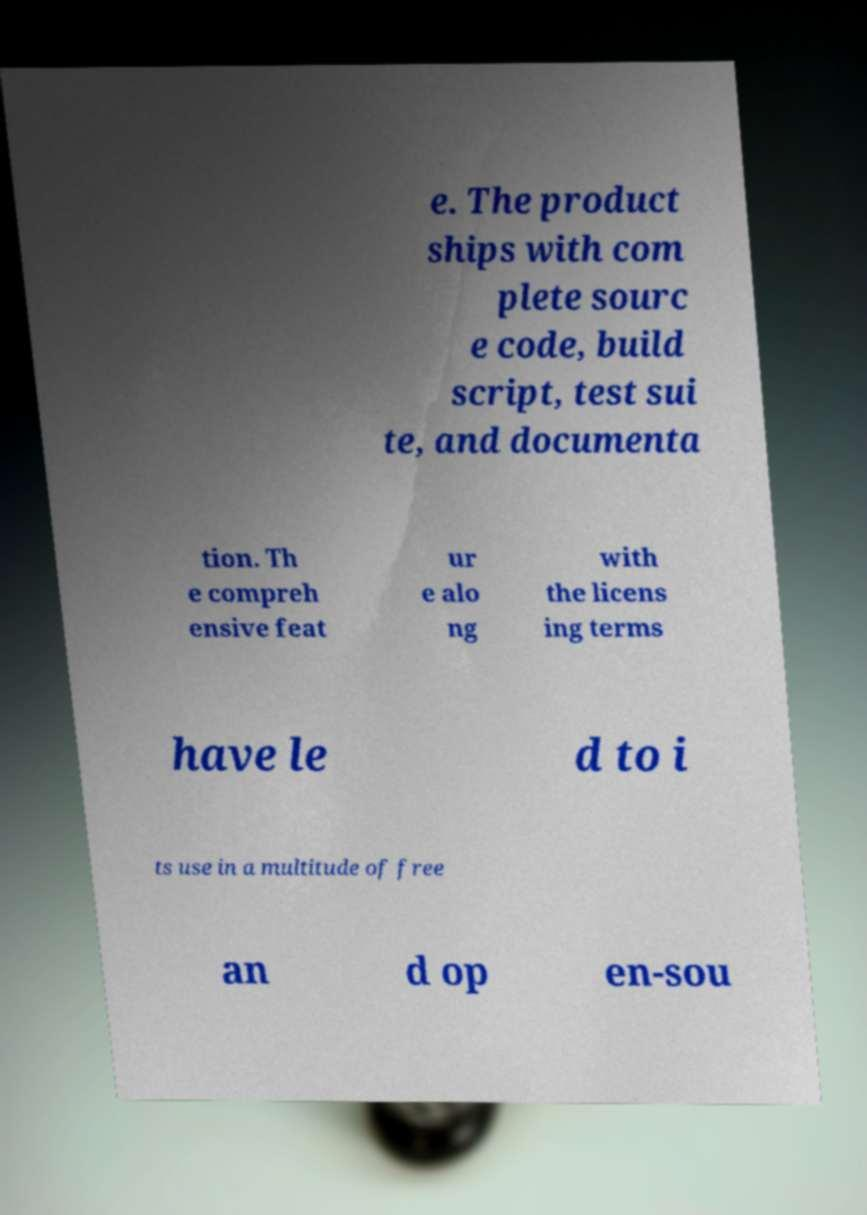Could you assist in decoding the text presented in this image and type it out clearly? e. The product ships with com plete sourc e code, build script, test sui te, and documenta tion. Th e compreh ensive feat ur e alo ng with the licens ing terms have le d to i ts use in a multitude of free an d op en-sou 